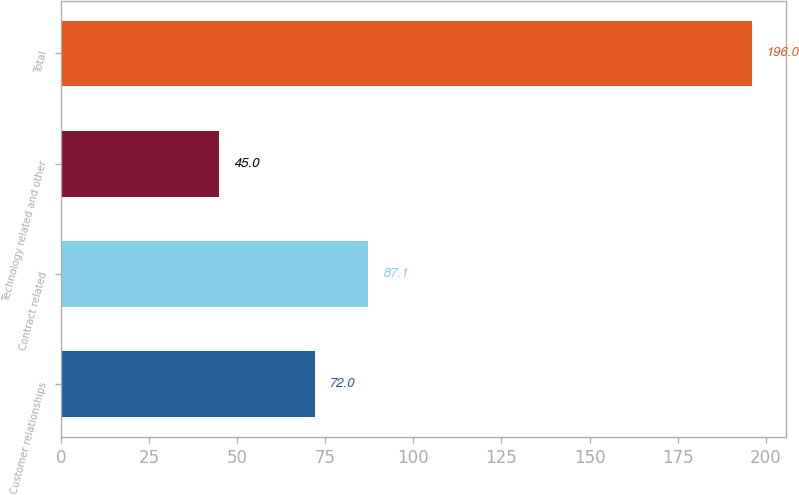Convert chart to OTSL. <chart><loc_0><loc_0><loc_500><loc_500><bar_chart><fcel>Customer relationships<fcel>Contract related<fcel>Technology related and other<fcel>Total<nl><fcel>72<fcel>87.1<fcel>45<fcel>196<nl></chart> 